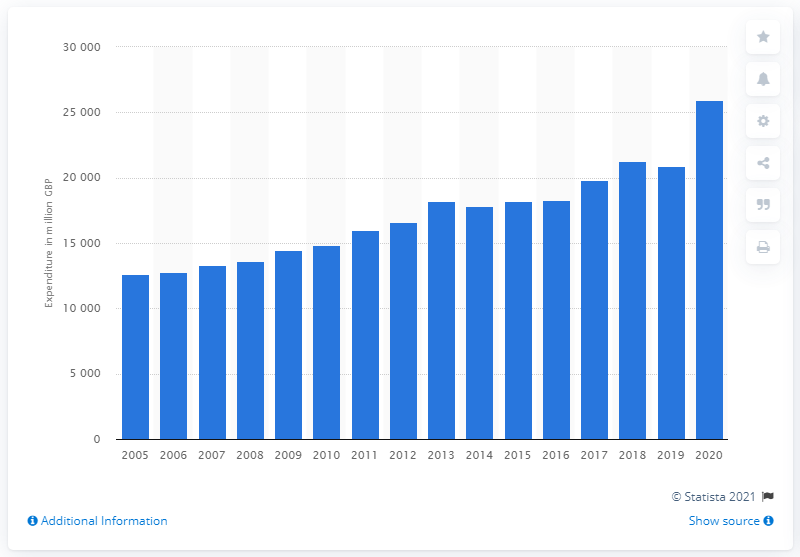Could you explain the trend in spending on alcoholic drinks over the years shown in this chart? The chart illustrates a general upward trend in spending on alcoholic drinks in the UK over the years ranging from 2005 to 2020. Despite minor fluctuations, the overall pattern suggests a consistent increase. One potential reason for this could be population growth, inflation, changes in consumer habits, or economic conditions fostering greater spending power. 